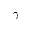<formula> <loc_0><loc_0><loc_500><loc_500>\gamma</formula> 